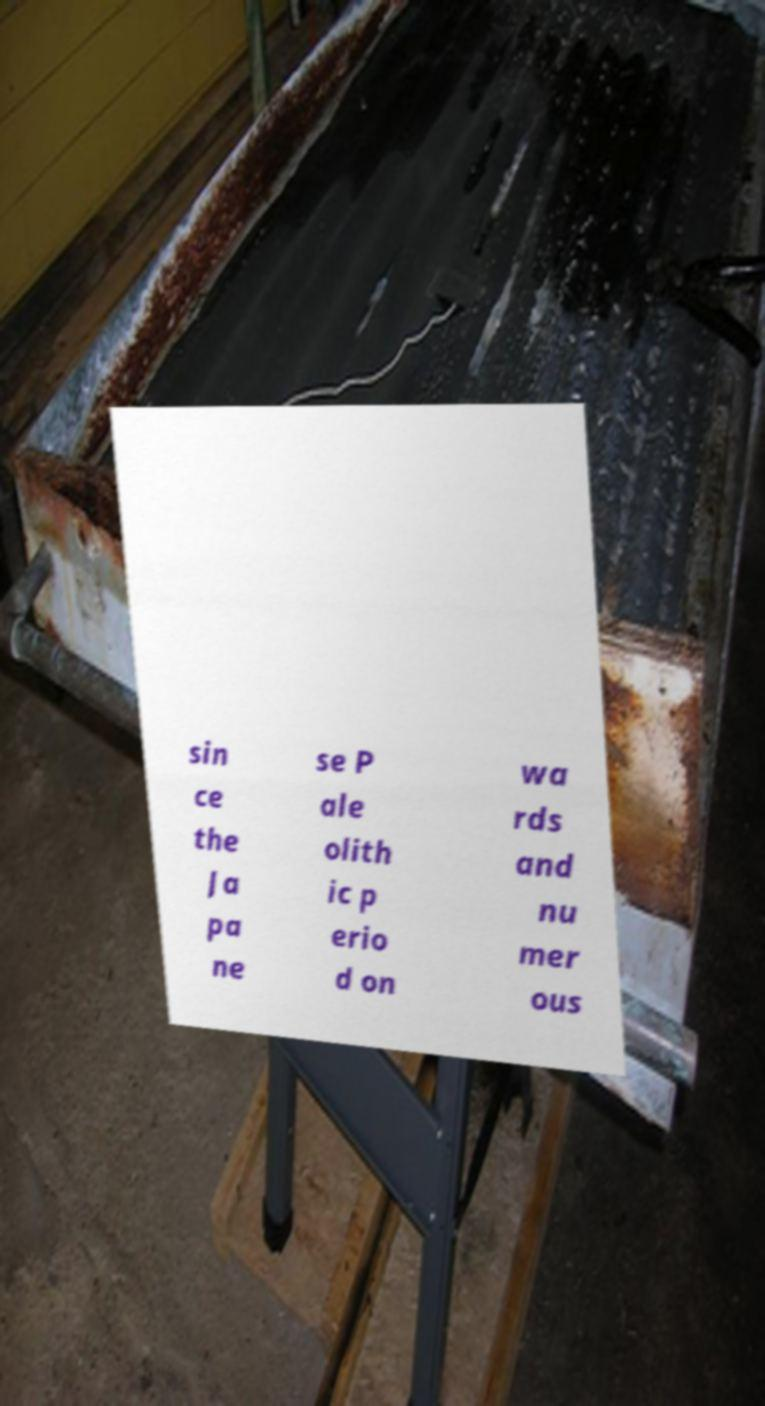Could you assist in decoding the text presented in this image and type it out clearly? sin ce the Ja pa ne se P ale olith ic p erio d on wa rds and nu mer ous 